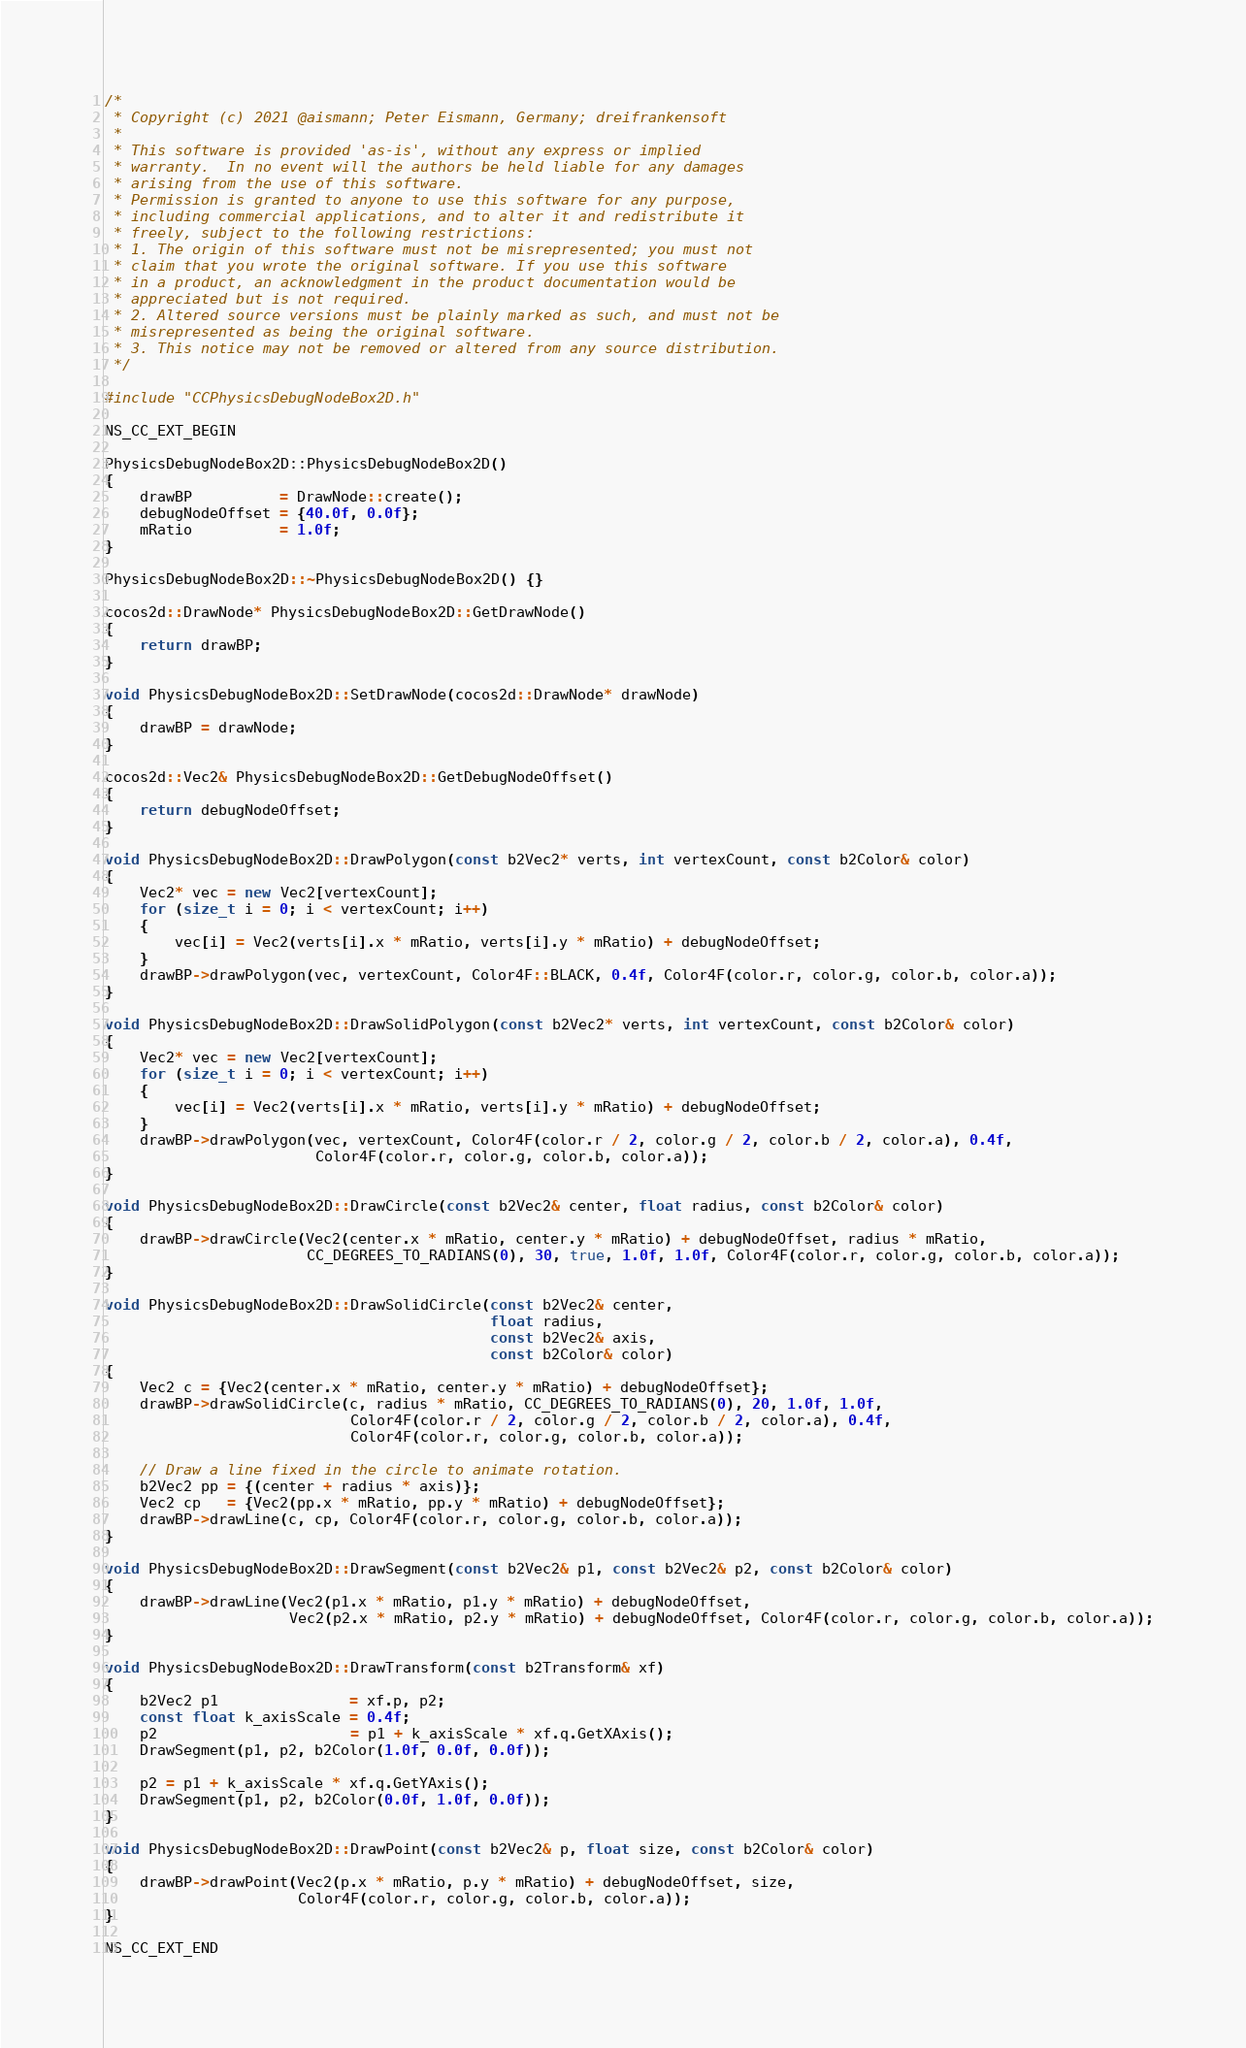<code> <loc_0><loc_0><loc_500><loc_500><_C++_>/*
 * Copyright (c) 2021 @aismann; Peter Eismann, Germany; dreifrankensoft
 *
 * This software is provided 'as-is', without any express or implied
 * warranty.  In no event will the authors be held liable for any damages
 * arising from the use of this software.
 * Permission is granted to anyone to use this software for any purpose,
 * including commercial applications, and to alter it and redistribute it
 * freely, subject to the following restrictions:
 * 1. The origin of this software must not be misrepresented; you must not
 * claim that you wrote the original software. If you use this software
 * in a product, an acknowledgment in the product documentation would be
 * appreciated but is not required.
 * 2. Altered source versions must be plainly marked as such, and must not be
 * misrepresented as being the original software.
 * 3. This notice may not be removed or altered from any source distribution.
 */

#include "CCPhysicsDebugNodeBox2D.h"

NS_CC_EXT_BEGIN

PhysicsDebugNodeBox2D::PhysicsDebugNodeBox2D()
{
    drawBP          = DrawNode::create();
    debugNodeOffset = {40.0f, 0.0f};
    mRatio          = 1.0f;
}

PhysicsDebugNodeBox2D::~PhysicsDebugNodeBox2D() {}

cocos2d::DrawNode* PhysicsDebugNodeBox2D::GetDrawNode()
{
    return drawBP;
}

void PhysicsDebugNodeBox2D::SetDrawNode(cocos2d::DrawNode* drawNode)
{
    drawBP = drawNode;
}

cocos2d::Vec2& PhysicsDebugNodeBox2D::GetDebugNodeOffset()
{
    return debugNodeOffset;
}

void PhysicsDebugNodeBox2D::DrawPolygon(const b2Vec2* verts, int vertexCount, const b2Color& color)
{
    Vec2* vec = new Vec2[vertexCount];
    for (size_t i = 0; i < vertexCount; i++)
    {
        vec[i] = Vec2(verts[i].x * mRatio, verts[i].y * mRatio) + debugNodeOffset;
    }
    drawBP->drawPolygon(vec, vertexCount, Color4F::BLACK, 0.4f, Color4F(color.r, color.g, color.b, color.a));
}

void PhysicsDebugNodeBox2D::DrawSolidPolygon(const b2Vec2* verts, int vertexCount, const b2Color& color)
{
    Vec2* vec = new Vec2[vertexCount];
    for (size_t i = 0; i < vertexCount; i++)
    {
        vec[i] = Vec2(verts[i].x * mRatio, verts[i].y * mRatio) + debugNodeOffset;
    }
    drawBP->drawPolygon(vec, vertexCount, Color4F(color.r / 2, color.g / 2, color.b / 2, color.a), 0.4f,
                        Color4F(color.r, color.g, color.b, color.a));
}

void PhysicsDebugNodeBox2D::DrawCircle(const b2Vec2& center, float radius, const b2Color& color)
{
    drawBP->drawCircle(Vec2(center.x * mRatio, center.y * mRatio) + debugNodeOffset, radius * mRatio,
                       CC_DEGREES_TO_RADIANS(0), 30, true, 1.0f, 1.0f, Color4F(color.r, color.g, color.b, color.a));
}

void PhysicsDebugNodeBox2D::DrawSolidCircle(const b2Vec2& center,
                                            float radius,
                                            const b2Vec2& axis,
                                            const b2Color& color)
{
    Vec2 c = {Vec2(center.x * mRatio, center.y * mRatio) + debugNodeOffset};
    drawBP->drawSolidCircle(c, radius * mRatio, CC_DEGREES_TO_RADIANS(0), 20, 1.0f, 1.0f,
                            Color4F(color.r / 2, color.g / 2, color.b / 2, color.a), 0.4f,
                            Color4F(color.r, color.g, color.b, color.a));

    // Draw a line fixed in the circle to animate rotation.
    b2Vec2 pp = {(center + radius * axis)};
    Vec2 cp   = {Vec2(pp.x * mRatio, pp.y * mRatio) + debugNodeOffset};
    drawBP->drawLine(c, cp, Color4F(color.r, color.g, color.b, color.a));
}

void PhysicsDebugNodeBox2D::DrawSegment(const b2Vec2& p1, const b2Vec2& p2, const b2Color& color)
{
    drawBP->drawLine(Vec2(p1.x * mRatio, p1.y * mRatio) + debugNodeOffset,
                     Vec2(p2.x * mRatio, p2.y * mRatio) + debugNodeOffset, Color4F(color.r, color.g, color.b, color.a));
}

void PhysicsDebugNodeBox2D::DrawTransform(const b2Transform& xf)
{
    b2Vec2 p1               = xf.p, p2;
    const float k_axisScale = 0.4f;
    p2                      = p1 + k_axisScale * xf.q.GetXAxis();
    DrawSegment(p1, p2, b2Color(1.0f, 0.0f, 0.0f));

    p2 = p1 + k_axisScale * xf.q.GetYAxis();
    DrawSegment(p1, p2, b2Color(0.0f, 1.0f, 0.0f));
}

void PhysicsDebugNodeBox2D::DrawPoint(const b2Vec2& p, float size, const b2Color& color)
{
    drawBP->drawPoint(Vec2(p.x * mRatio, p.y * mRatio) + debugNodeOffset, size,
                      Color4F(color.r, color.g, color.b, color.a));
}

NS_CC_EXT_END</code> 